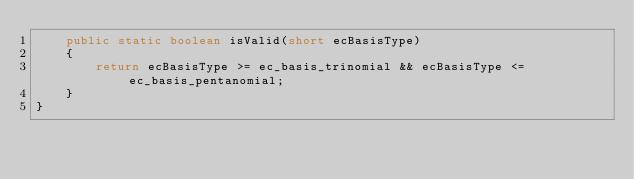<code> <loc_0><loc_0><loc_500><loc_500><_Java_>    public static boolean isValid(short ecBasisType)
    {
        return ecBasisType >= ec_basis_trinomial && ecBasisType <= ec_basis_pentanomial;
    }
}
</code> 